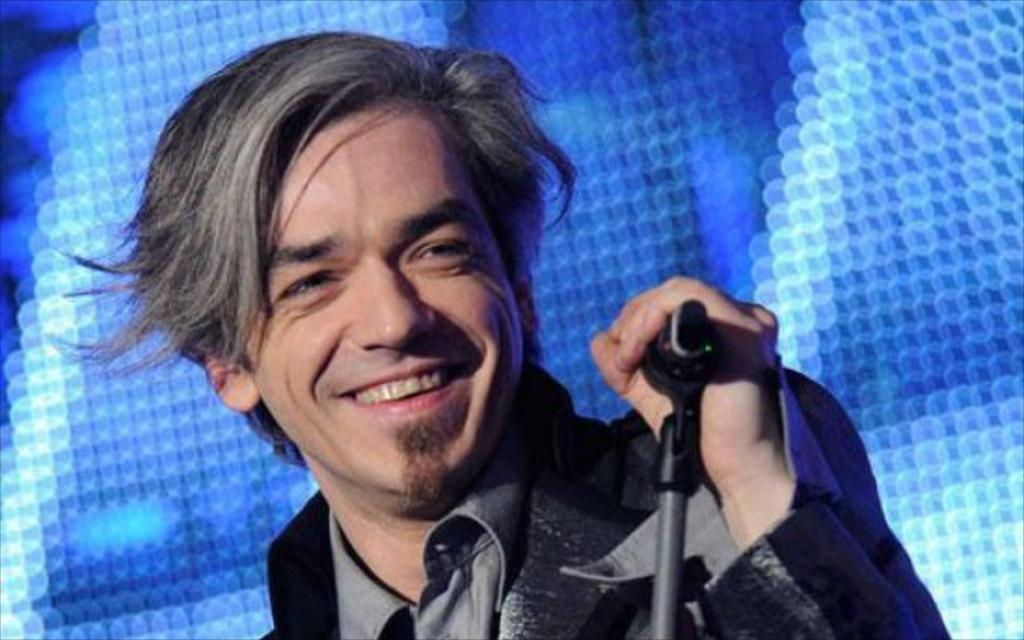Who is present in the image? There is a man in the image. What is the man wearing? The man is wearing a black jacket. What object can be seen in the image that is typically used for amplifying sound? There is a microphone in the image, and it is on a stand. What color is the background of the image? The background of the image is blue. What type of riddle can be solved using the seed in the image? There is no seed present in the image, so it cannot be used to solve any riddles. 